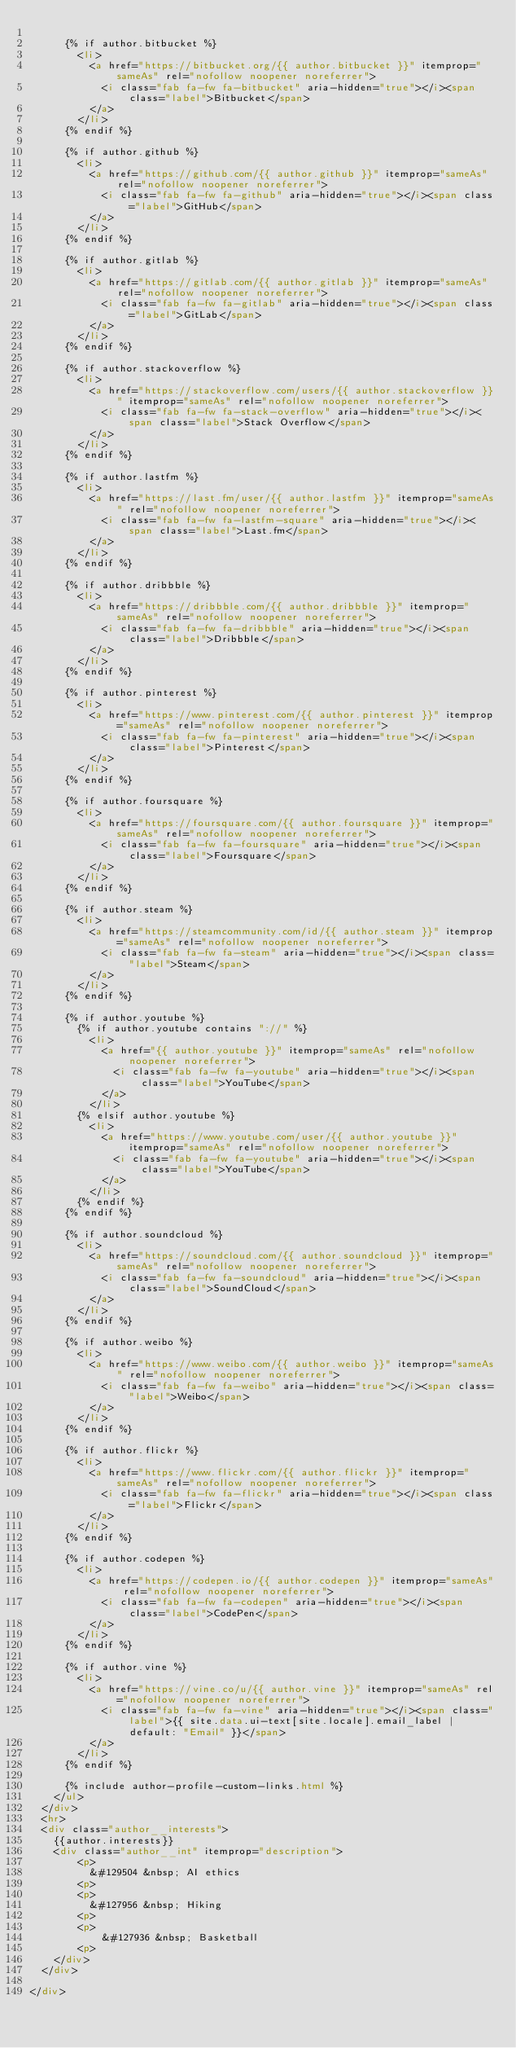Convert code to text. <code><loc_0><loc_0><loc_500><loc_500><_HTML_>
      {% if author.bitbucket %}
        <li>
          <a href="https://bitbucket.org/{{ author.bitbucket }}" itemprop="sameAs" rel="nofollow noopener noreferrer">
            <i class="fab fa-fw fa-bitbucket" aria-hidden="true"></i><span class="label">Bitbucket</span>
          </a>
        </li>
      {% endif %}

      {% if author.github %}
        <li>
          <a href="https://github.com/{{ author.github }}" itemprop="sameAs" rel="nofollow noopener noreferrer">
            <i class="fab fa-fw fa-github" aria-hidden="true"></i><span class="label">GitHub</span>
          </a>
        </li>
      {% endif %}

      {% if author.gitlab %}
        <li>
          <a href="https://gitlab.com/{{ author.gitlab }}" itemprop="sameAs" rel="nofollow noopener noreferrer">
            <i class="fab fa-fw fa-gitlab" aria-hidden="true"></i><span class="label">GitLab</span>
          </a>
        </li>
      {% endif %}

      {% if author.stackoverflow %}
        <li>
          <a href="https://stackoverflow.com/users/{{ author.stackoverflow }}" itemprop="sameAs" rel="nofollow noopener noreferrer">
            <i class="fab fa-fw fa-stack-overflow" aria-hidden="true"></i><span class="label">Stack Overflow</span>
          </a>
        </li>
      {% endif %}

      {% if author.lastfm %}
        <li>
          <a href="https://last.fm/user/{{ author.lastfm }}" itemprop="sameAs" rel="nofollow noopener noreferrer">
            <i class="fab fa-fw fa-lastfm-square" aria-hidden="true"></i><span class="label">Last.fm</span>
          </a>
        </li>
      {% endif %}

      {% if author.dribbble %}
        <li>
          <a href="https://dribbble.com/{{ author.dribbble }}" itemprop="sameAs" rel="nofollow noopener noreferrer">
            <i class="fab fa-fw fa-dribbble" aria-hidden="true"></i><span class="label">Dribbble</span>
          </a>
        </li>
      {% endif %}

      {% if author.pinterest %}
        <li>
          <a href="https://www.pinterest.com/{{ author.pinterest }}" itemprop="sameAs" rel="nofollow noopener noreferrer">
            <i class="fab fa-fw fa-pinterest" aria-hidden="true"></i><span class="label">Pinterest</span>
          </a>
        </li>
      {% endif %}

      {% if author.foursquare %}
        <li>
          <a href="https://foursquare.com/{{ author.foursquare }}" itemprop="sameAs" rel="nofollow noopener noreferrer">
            <i class="fab fa-fw fa-foursquare" aria-hidden="true"></i><span class="label">Foursquare</span>
          </a>
        </li>
      {% endif %}

      {% if author.steam %}
        <li>
          <a href="https://steamcommunity.com/id/{{ author.steam }}" itemprop="sameAs" rel="nofollow noopener noreferrer">
            <i class="fab fa-fw fa-steam" aria-hidden="true"></i><span class="label">Steam</span>
          </a>
        </li>
      {% endif %}

      {% if author.youtube %}
        {% if author.youtube contains "://" %}
          <li>
            <a href="{{ author.youtube }}" itemprop="sameAs" rel="nofollow noopener noreferrer">
              <i class="fab fa-fw fa-youtube" aria-hidden="true"></i><span class="label">YouTube</span>
            </a>
          </li>
        {% elsif author.youtube %}
          <li>
            <a href="https://www.youtube.com/user/{{ author.youtube }}" itemprop="sameAs" rel="nofollow noopener noreferrer">
              <i class="fab fa-fw fa-youtube" aria-hidden="true"></i><span class="label">YouTube</span>
            </a>
          </li>
        {% endif %}
      {% endif %}

      {% if author.soundcloud %}
        <li>
          <a href="https://soundcloud.com/{{ author.soundcloud }}" itemprop="sameAs" rel="nofollow noopener noreferrer">
            <i class="fab fa-fw fa-soundcloud" aria-hidden="true"></i><span class="label">SoundCloud</span>
          </a>
        </li>
      {% endif %}

      {% if author.weibo %}
        <li>
          <a href="https://www.weibo.com/{{ author.weibo }}" itemprop="sameAs" rel="nofollow noopener noreferrer">
            <i class="fab fa-fw fa-weibo" aria-hidden="true"></i><span class="label">Weibo</span>
          </a>
        </li>
      {% endif %}

      {% if author.flickr %}
        <li>
          <a href="https://www.flickr.com/{{ author.flickr }}" itemprop="sameAs" rel="nofollow noopener noreferrer">
            <i class="fab fa-fw fa-flickr" aria-hidden="true"></i><span class="label">Flickr</span>
          </a>
        </li>
      {% endif %}

      {% if author.codepen %}
        <li>
          <a href="https://codepen.io/{{ author.codepen }}" itemprop="sameAs" rel="nofollow noopener noreferrer">
            <i class="fab fa-fw fa-codepen" aria-hidden="true"></i><span class="label">CodePen</span>
          </a>
        </li>
      {% endif %}

      {% if author.vine %}
        <li>
          <a href="https://vine.co/u/{{ author.vine }}" itemprop="sameAs" rel="nofollow noopener noreferrer">
            <i class="fab fa-fw fa-vine" aria-hidden="true"></i><span class="label">{{ site.data.ui-text[site.locale].email_label | default: "Email" }}</span>
          </a>
        </li>
      {% endif %}

      {% include author-profile-custom-links.html %}
    </ul>
  </div>
  <hr>
  <div class="author__interests">
    {{author.interests}}
    <div class="author__int" itemprop="description">
        <p>
          &#129504 &nbsp; AI ethics
        <p>
        <p>
          &#127956 &nbsp; Hiking
        <p>
        <p>
            &#127936 &nbsp; Basketball
        <p>
    </div>
  </div>

</div>

</code> 